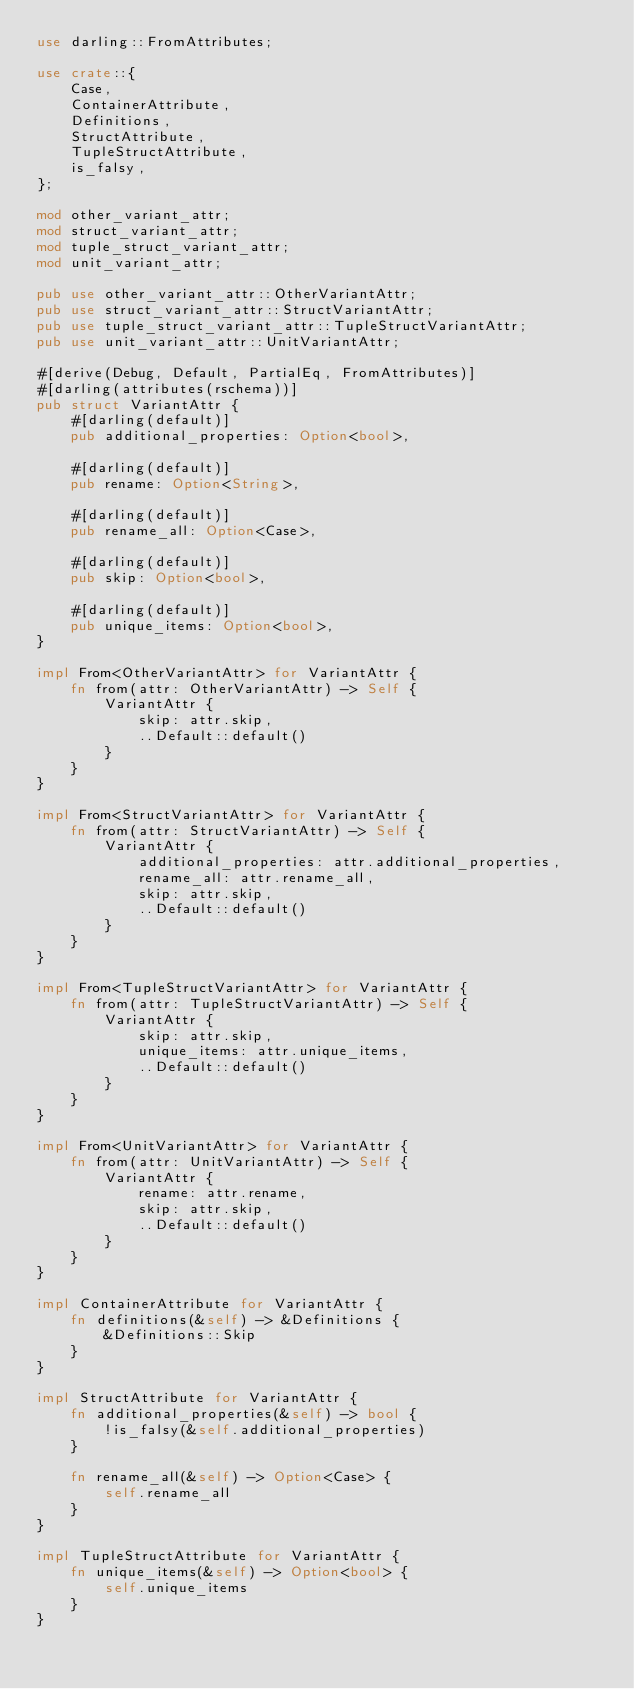<code> <loc_0><loc_0><loc_500><loc_500><_Rust_>use darling::FromAttributes;

use crate::{
    Case,
    ContainerAttribute,
    Definitions,
    StructAttribute,
    TupleStructAttribute,
    is_falsy,
};

mod other_variant_attr;
mod struct_variant_attr;
mod tuple_struct_variant_attr;
mod unit_variant_attr;

pub use other_variant_attr::OtherVariantAttr;
pub use struct_variant_attr::StructVariantAttr;
pub use tuple_struct_variant_attr::TupleStructVariantAttr;
pub use unit_variant_attr::UnitVariantAttr;

#[derive(Debug, Default, PartialEq, FromAttributes)]
#[darling(attributes(rschema))]
pub struct VariantAttr {
    #[darling(default)]
    pub additional_properties: Option<bool>,

    #[darling(default)]
    pub rename: Option<String>,

    #[darling(default)]
    pub rename_all: Option<Case>,

    #[darling(default)]
    pub skip: Option<bool>,

    #[darling(default)]
    pub unique_items: Option<bool>,
}

impl From<OtherVariantAttr> for VariantAttr {
    fn from(attr: OtherVariantAttr) -> Self {
        VariantAttr {
            skip: attr.skip,
            ..Default::default()
        }
    }
}

impl From<StructVariantAttr> for VariantAttr {
    fn from(attr: StructVariantAttr) -> Self {
        VariantAttr {
            additional_properties: attr.additional_properties,
            rename_all: attr.rename_all,
            skip: attr.skip,
            ..Default::default()
        }
    }
}

impl From<TupleStructVariantAttr> for VariantAttr {
    fn from(attr: TupleStructVariantAttr) -> Self {
        VariantAttr {
            skip: attr.skip,
            unique_items: attr.unique_items,
            ..Default::default()
        }
    }
}

impl From<UnitVariantAttr> for VariantAttr {
    fn from(attr: UnitVariantAttr) -> Self {
        VariantAttr {
            rename: attr.rename,
            skip: attr.skip,
            ..Default::default()
        }
    }
}

impl ContainerAttribute for VariantAttr {
    fn definitions(&self) -> &Definitions {
        &Definitions::Skip
    }
}

impl StructAttribute for VariantAttr {
    fn additional_properties(&self) -> bool {
        !is_falsy(&self.additional_properties)
    }

    fn rename_all(&self) -> Option<Case> {
        self.rename_all
    }
}

impl TupleStructAttribute for VariantAttr {
    fn unique_items(&self) -> Option<bool> {
        self.unique_items
    }
}
</code> 